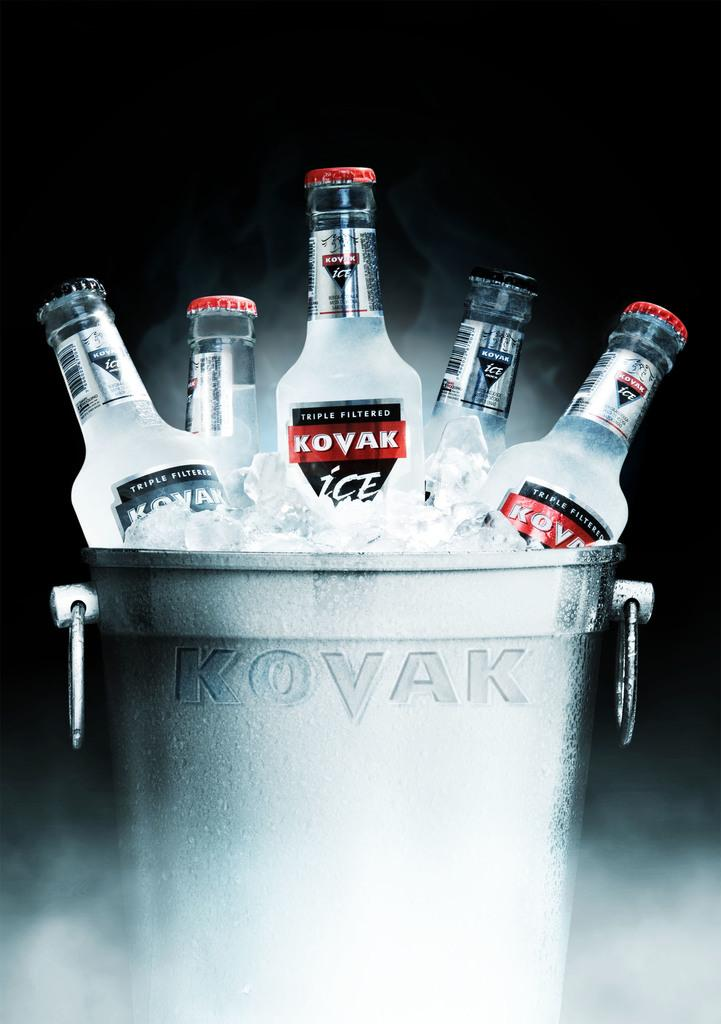<image>
Write a terse but informative summary of the picture. A silver bucket of Kovak Ice with ice inside the bucket 